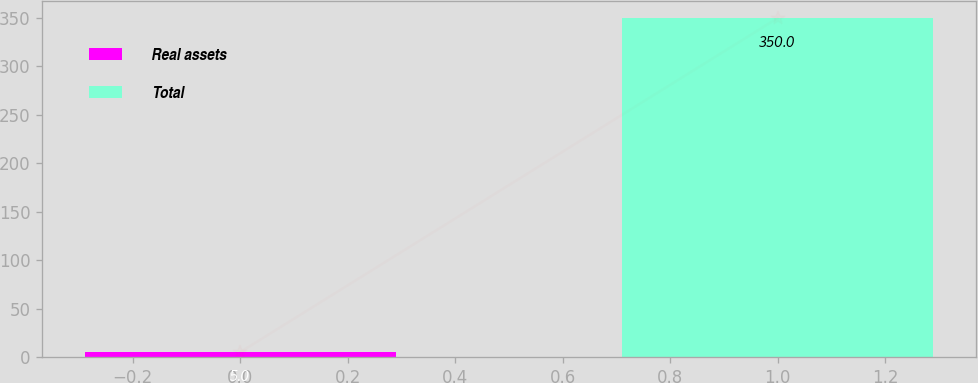Convert chart. <chart><loc_0><loc_0><loc_500><loc_500><bar_chart><fcel>Real assets<fcel>Total<nl><fcel>5<fcel>350<nl></chart> 